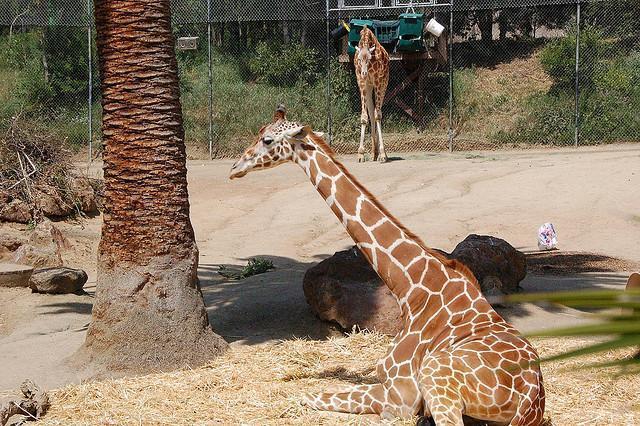How many giraffes are in the photo?
Give a very brief answer. 2. 